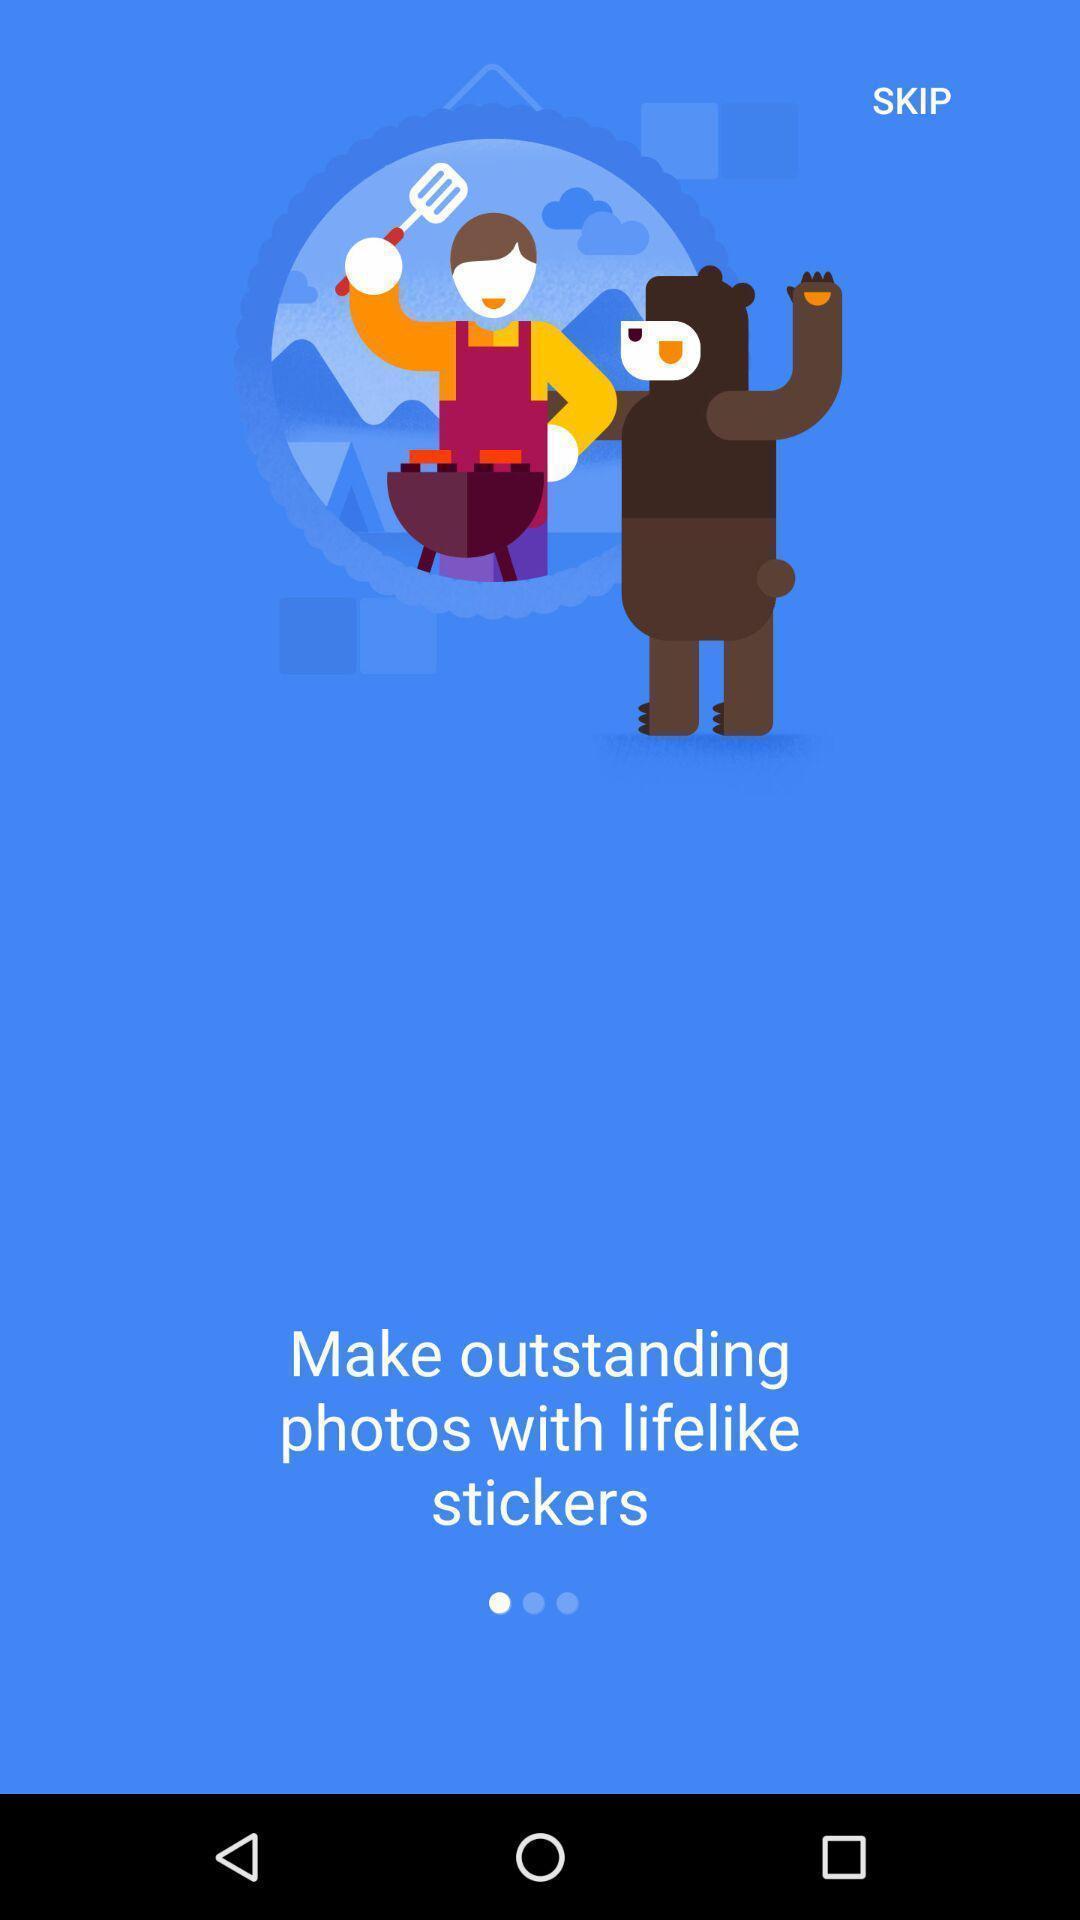Summarize the main components in this picture. Welcome page of a social app. Summarize the information in this screenshot. Welcome page displaying information about application. 